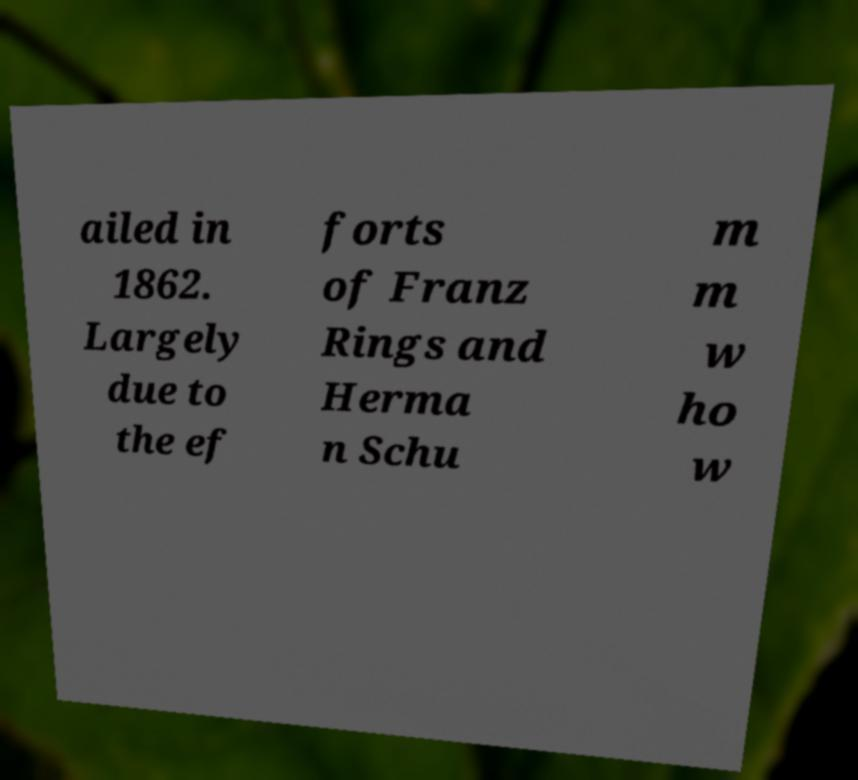There's text embedded in this image that I need extracted. Can you transcribe it verbatim? ailed in 1862. Largely due to the ef forts of Franz Rings and Herma n Schu m m w ho w 